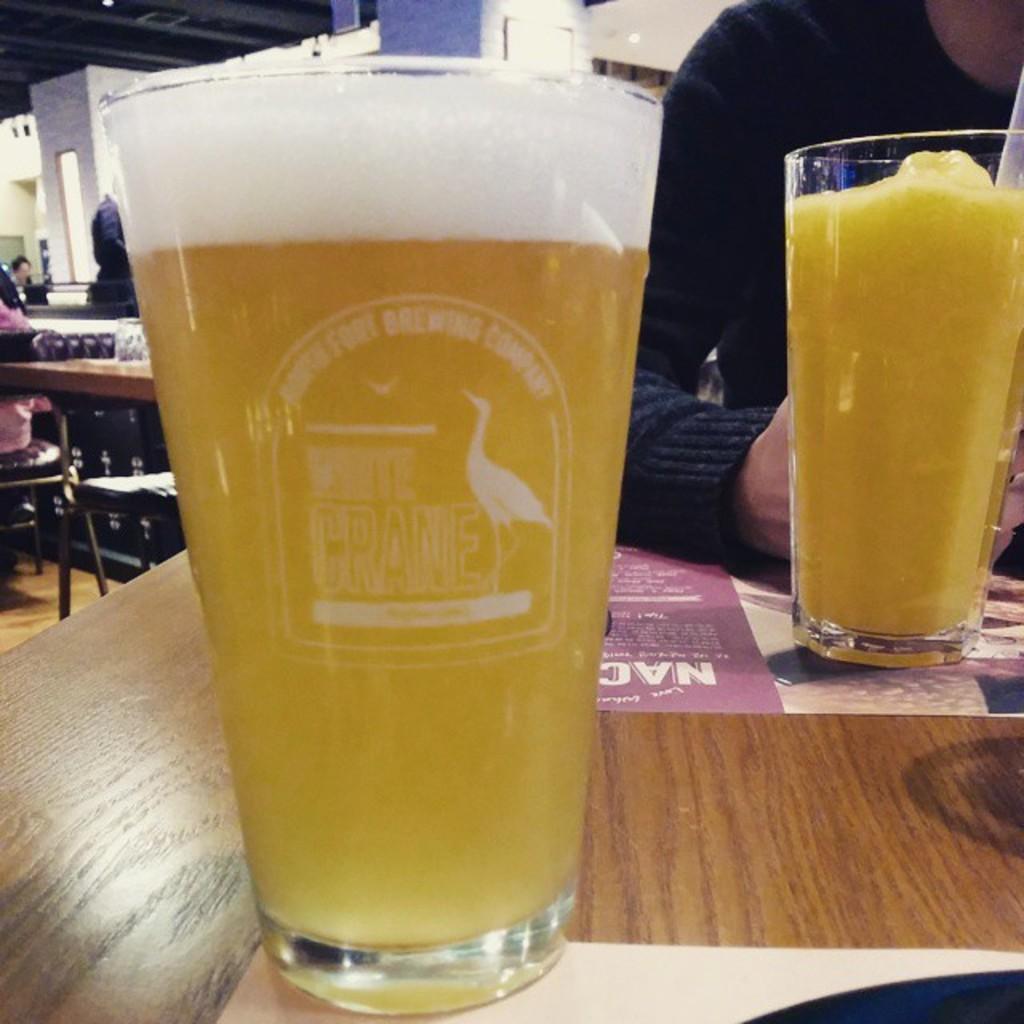In one or two sentences, can you explain what this image depicts? In the image we can see there is a table on which there are juice glasses. 